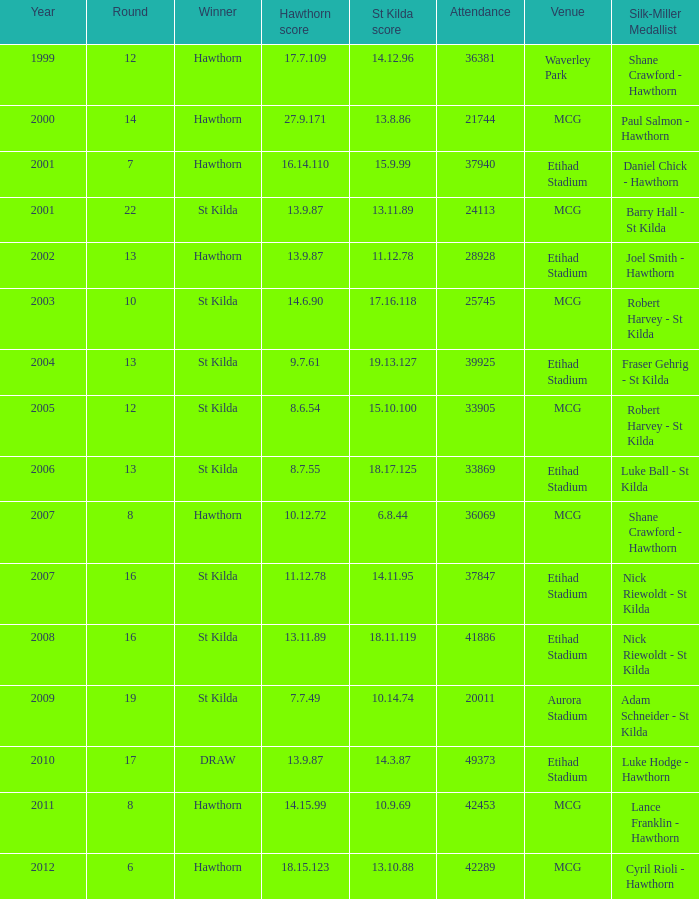What is the attendance when the st kilda score is 13.10.88? 42289.0. 